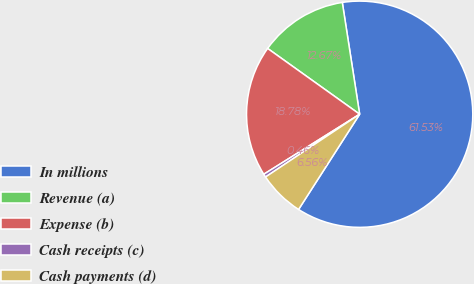Convert chart. <chart><loc_0><loc_0><loc_500><loc_500><pie_chart><fcel>In millions<fcel>Revenue (a)<fcel>Expense (b)<fcel>Cash receipts (c)<fcel>Cash payments (d)<nl><fcel>61.53%<fcel>12.67%<fcel>18.78%<fcel>0.46%<fcel>6.56%<nl></chart> 